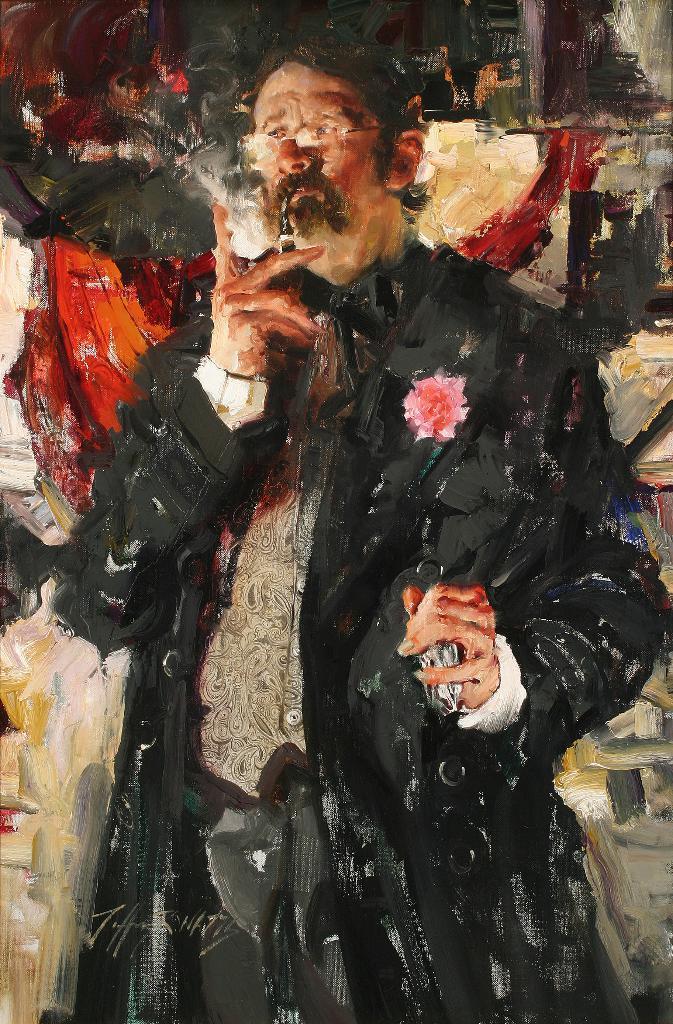Describe this image in one or two sentences. This is a painting in this picture in the center there is one man who is standing, and he is holding a cigarette in the background there is a wall. 